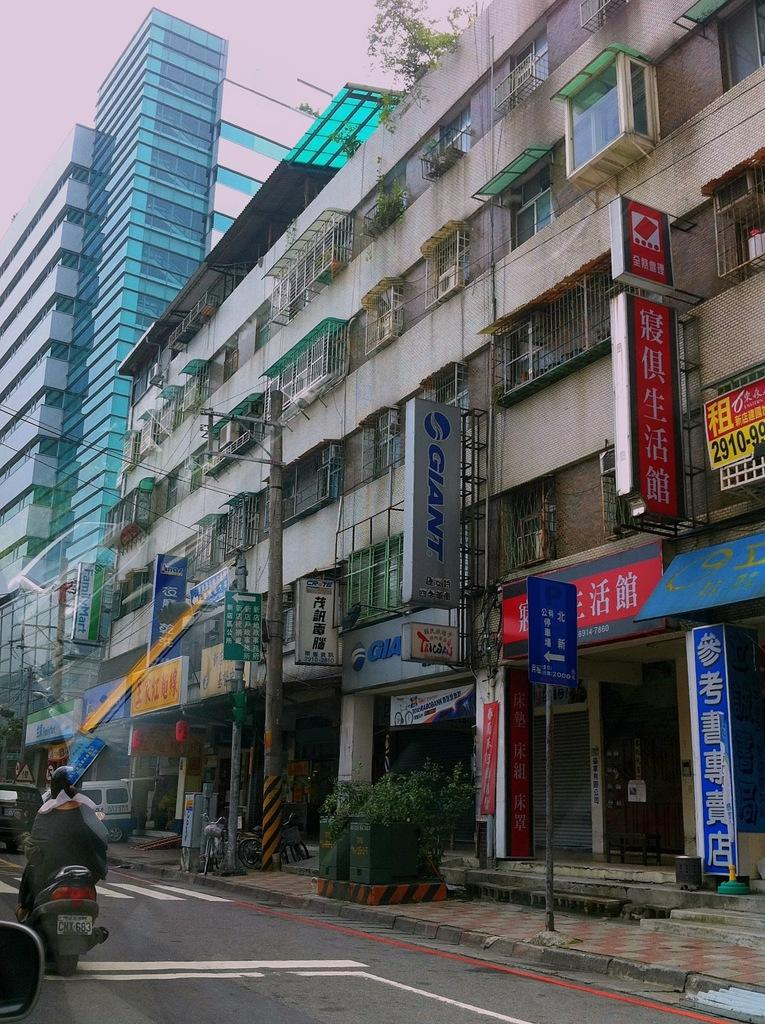What is the woman doing in the image? The woman is riding a bike in the image. Where is the woman riding her bike? The woman is on the road in the image. What can be seen on the right side of the image? There are buildings on the right side of the image. What objects are visible in the image besides the woman and the buildings? There are boards and poles visible in the image. Is there any path for pedestrians or cyclists in the image? Yes, there is a side path in the image. What is visible in the background of the image? The sky is visible in the image. Can you see any cherries growing on the trees in the image? There are no trees or cherries visible in the image. Is there any destruction happening in the image? There is no destruction or any indication of an event causing damage in the image. 